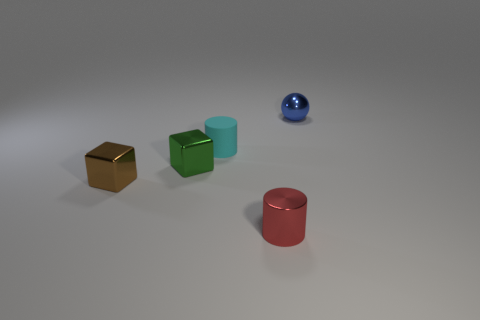Add 2 shiny objects. How many objects exist? 7 Subtract all balls. How many objects are left? 4 Add 4 small brown metallic things. How many small brown metallic things exist? 5 Subtract 1 cyan cylinders. How many objects are left? 4 Subtract all small cubes. Subtract all matte objects. How many objects are left? 2 Add 4 small red shiny objects. How many small red shiny objects are left? 5 